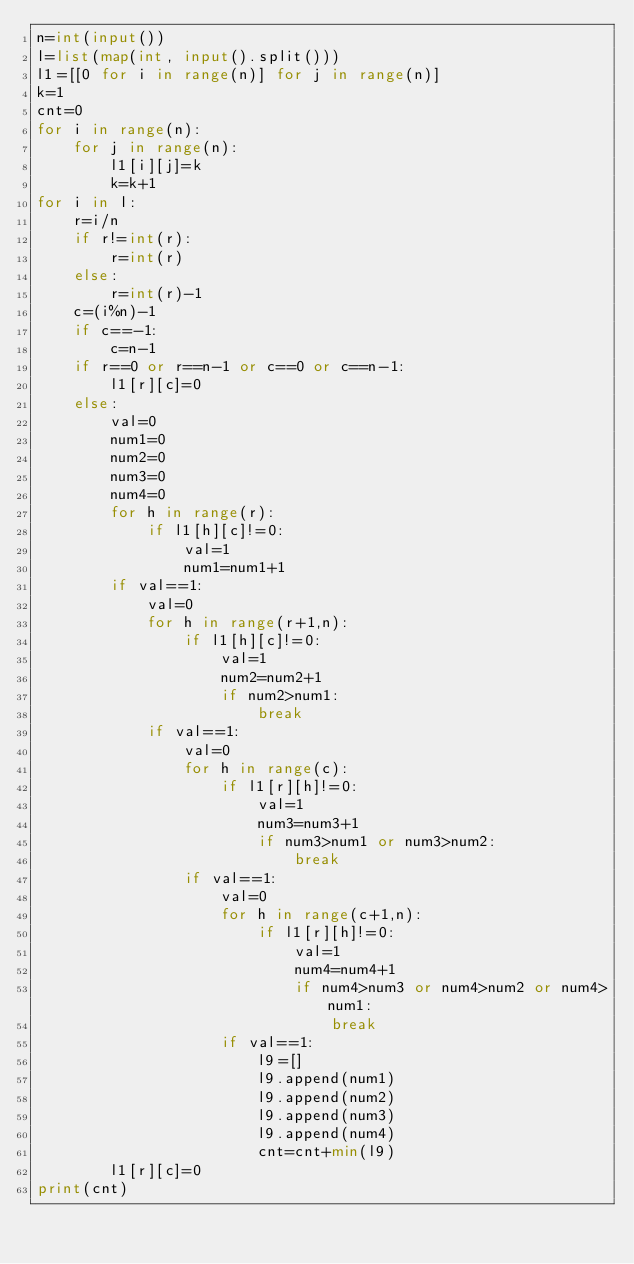<code> <loc_0><loc_0><loc_500><loc_500><_Python_>n=int(input())
l=list(map(int, input().split()))
l1=[[0 for i in range(n)] for j in range(n)]
k=1
cnt=0
for i in range(n):
    for j in range(n):
        l1[i][j]=k
        k=k+1
for i in l:
    r=i/n
    if r!=int(r):
        r=int(r)
    else:
        r=int(r)-1
    c=(i%n)-1
    if c==-1:
        c=n-1
    if r==0 or r==n-1 or c==0 or c==n-1:
        l1[r][c]=0
    else:
        val=0
        num1=0
        num2=0
        num3=0
        num4=0
        for h in range(r):
            if l1[h][c]!=0:
                val=1
                num1=num1+1
        if val==1:
            val=0
            for h in range(r+1,n):
                if l1[h][c]!=0:
                    val=1
                    num2=num2+1
                    if num2>num1:
                        break
            if val==1:
                val=0
                for h in range(c):
                    if l1[r][h]!=0:
                        val=1
                        num3=num3+1
                        if num3>num1 or num3>num2:
                            break
                if val==1:
                    val=0
                    for h in range(c+1,n):
                        if l1[r][h]!=0:
                            val=1
                            num4=num4+1
                            if num4>num3 or num4>num2 or num4>num1:
                                break
                    if val==1:
                        l9=[]
                        l9.append(num1)
                        l9.append(num2)
                        l9.append(num3)
                        l9.append(num4)
                        cnt=cnt+min(l9)
        l1[r][c]=0
print(cnt)</code> 